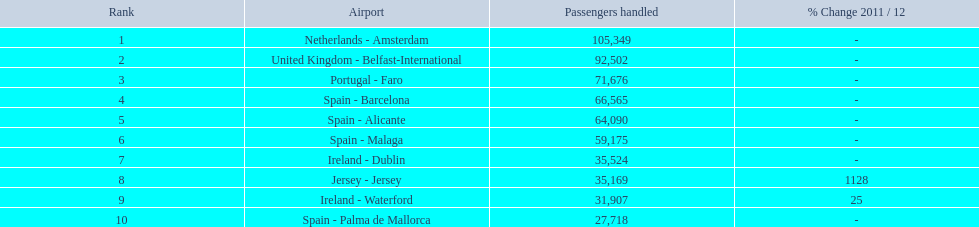What are the quantities of passengers managed along the various paths in the airport? 105,349, 92,502, 71,676, 66,565, 64,090, 59,175, 35,524, 35,169, 31,907, 27,718. Of these paths, which manages fewer than 30,000 passengers? Spain - Palma de Mallorca. What are the various destinations departing from the london southend airport? Netherlands - Amsterdam, United Kingdom - Belfast-International, Portugal - Faro, Spain - Barcelona, Spain - Alicante, Spain - Malaga, Ireland - Dublin, Jersey - Jersey, Ireland - Waterford, Spain - Palma de Mallorca. How many passengers have been processed by each destination? 105,349, 92,502, 71,676, 66,565, 64,090, 59,175, 35,524, 35,169, 31,907, 27,718. And out of those, which airport has catered to the fewest passengers? Spain - Palma de Mallorca. 